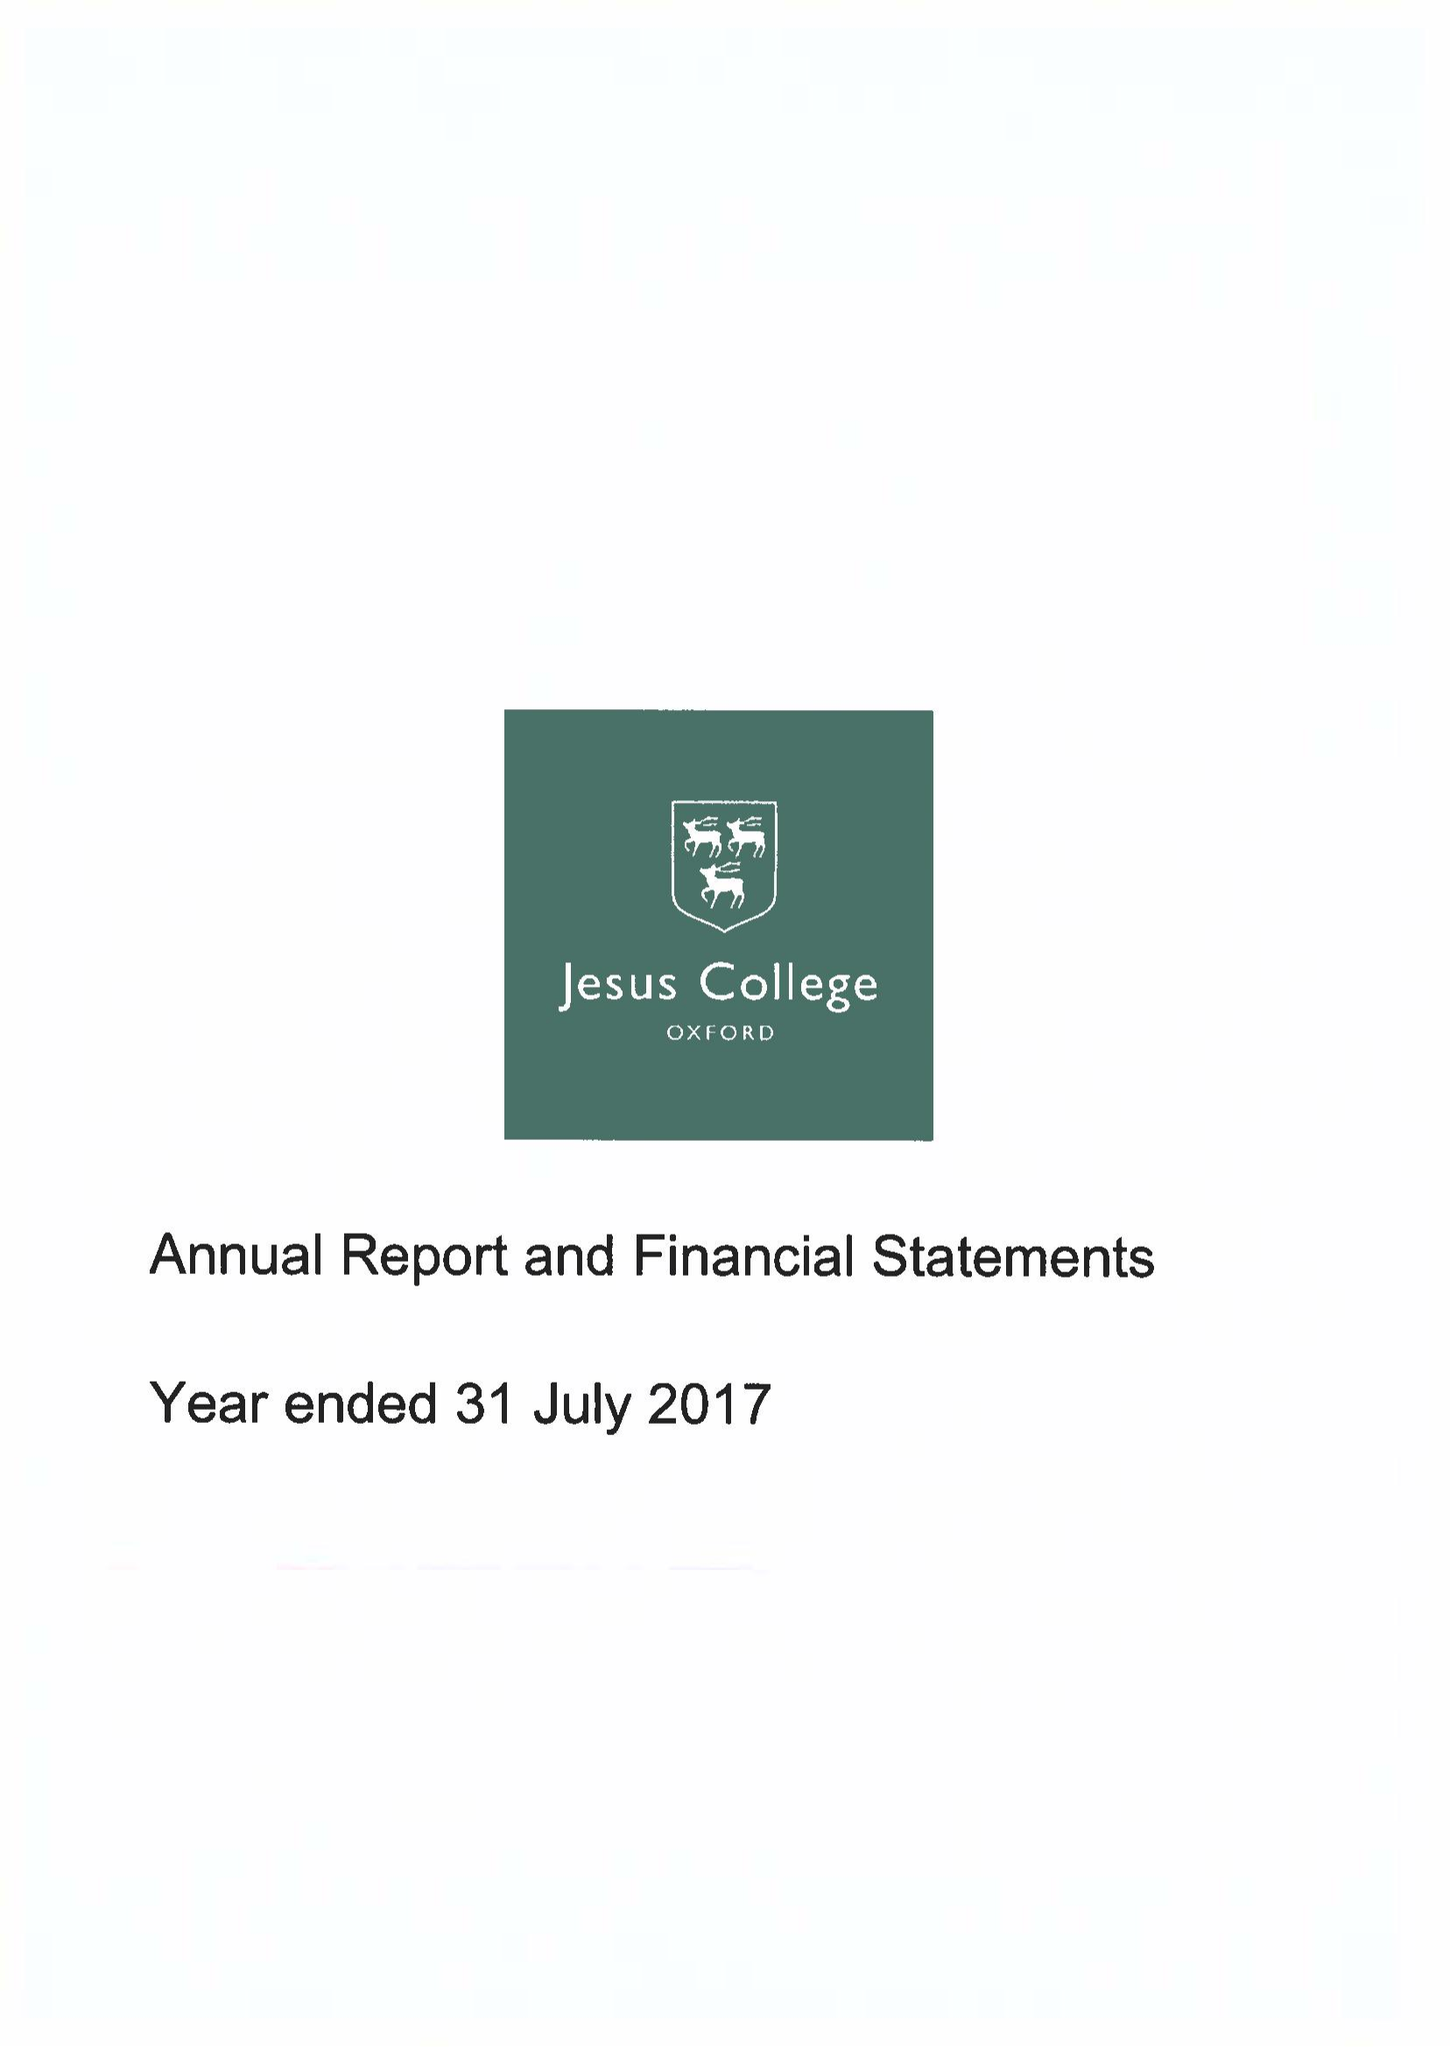What is the value for the spending_annually_in_british_pounds?
Answer the question using a single word or phrase. 12556000.00 